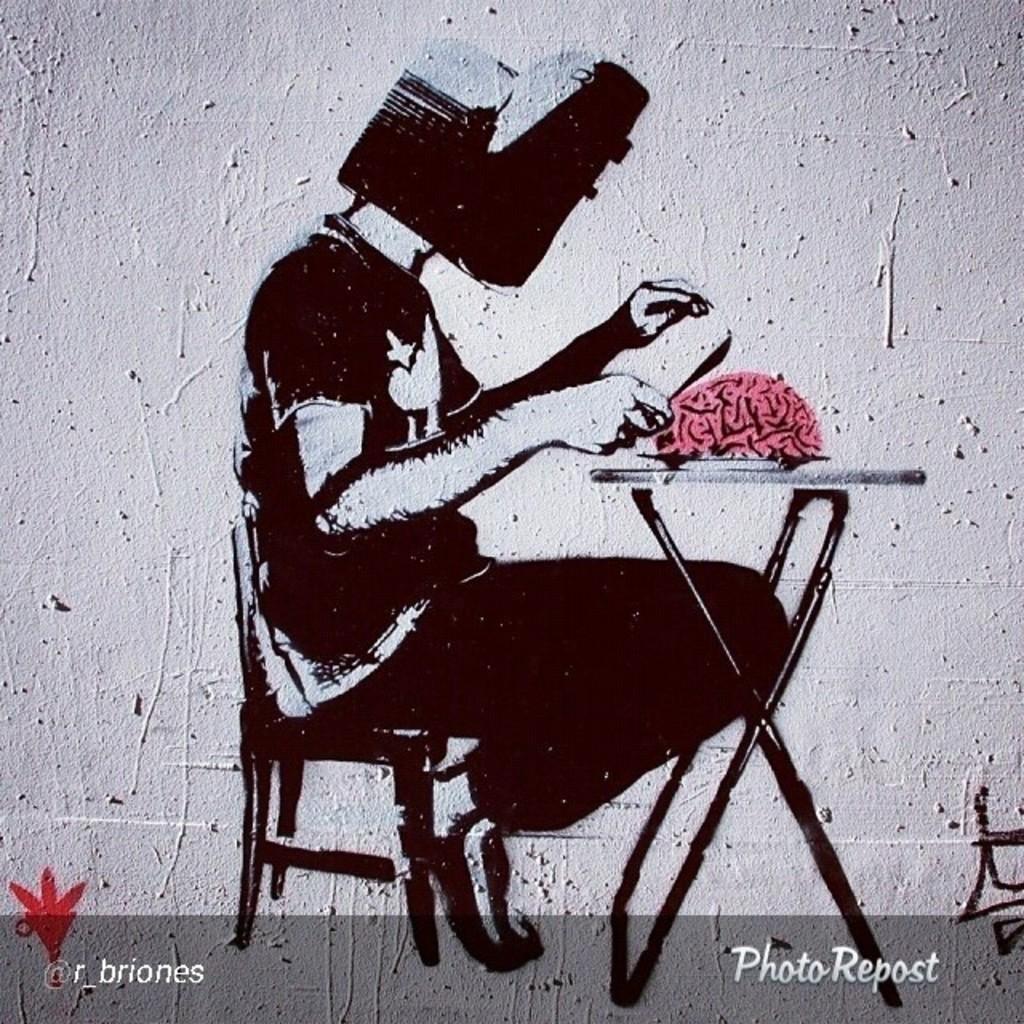Could you give a brief overview of what you see in this image? In this image we can see the wall and on the wall we can see the painting of some person sitting on the chair in front of the table and on the table we can see the brain. At the bottom we can see the text. 